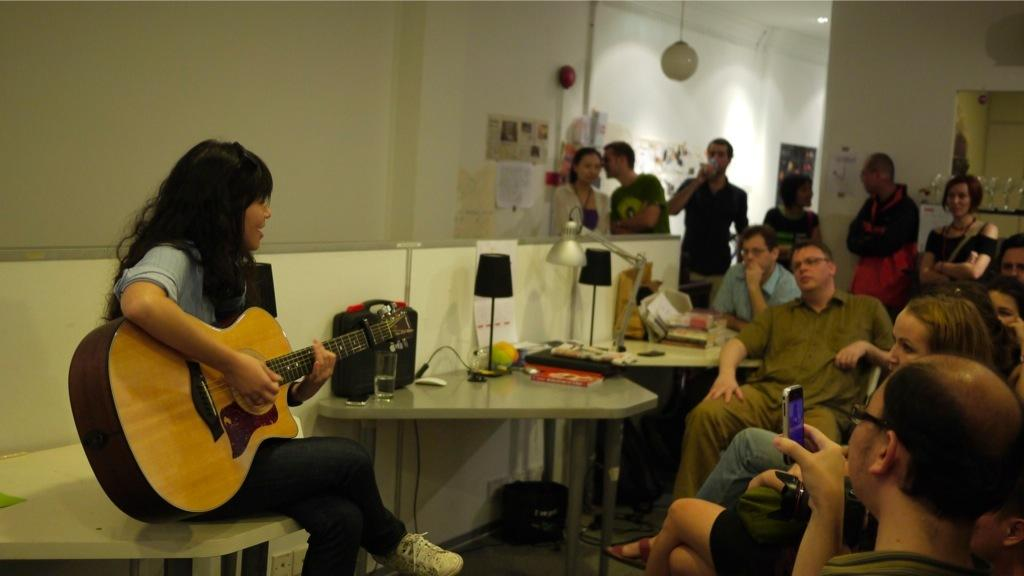What is the main activity taking place in the image? There is a person playing a guitar in the image. Where is the guitar player located in the image? The person playing the guitar is on the left side of the image. What are the other people in the image doing? There are people sitting and listening to the guitar player on the right side of the image, and there are people standing in the background of the image. What type of potato is being used as a microphone by the guitar player in the image? There is no potato present in the image, and the guitar player is not using a potato as a microphone. 